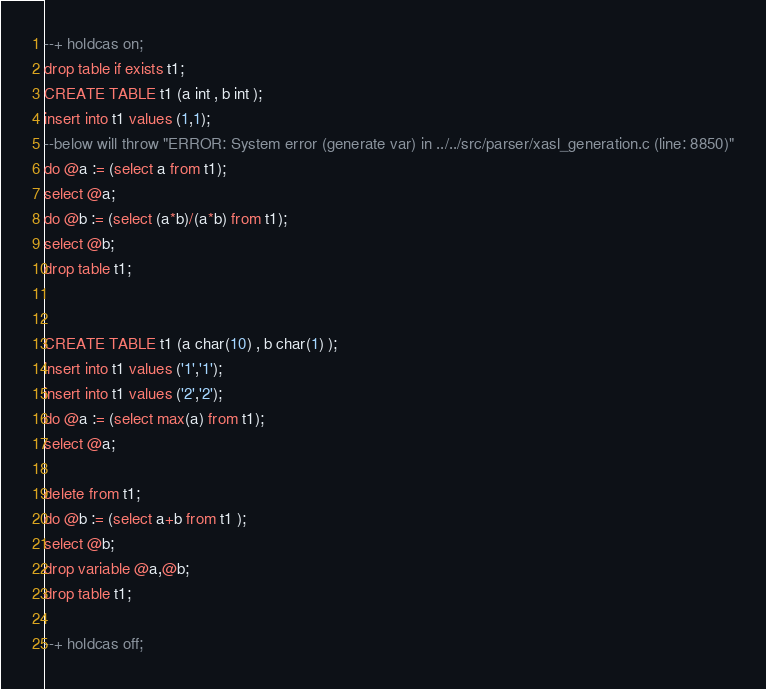<code> <loc_0><loc_0><loc_500><loc_500><_SQL_>--+ holdcas on;
drop table if exists t1;
CREATE TABLE t1 (a int , b int );
insert into t1 values (1,1);
--below will throw "ERROR: System error (generate var) in ../../src/parser/xasl_generation.c (line: 8850)"
do @a := (select a from t1);
select @a;
do @b := (select (a*b)/(a*b) from t1);
select @b;
drop table t1;


CREATE TABLE t1 (a char(10) , b char(1) );
insert into t1 values ('1','1');
insert into t1 values ('2','2');
do @a := (select max(a) from t1);
select @a;

delete from t1;
do @b := (select a+b from t1 );
select @b;
drop variable @a,@b;
drop table t1;

--+ holdcas off;
</code> 